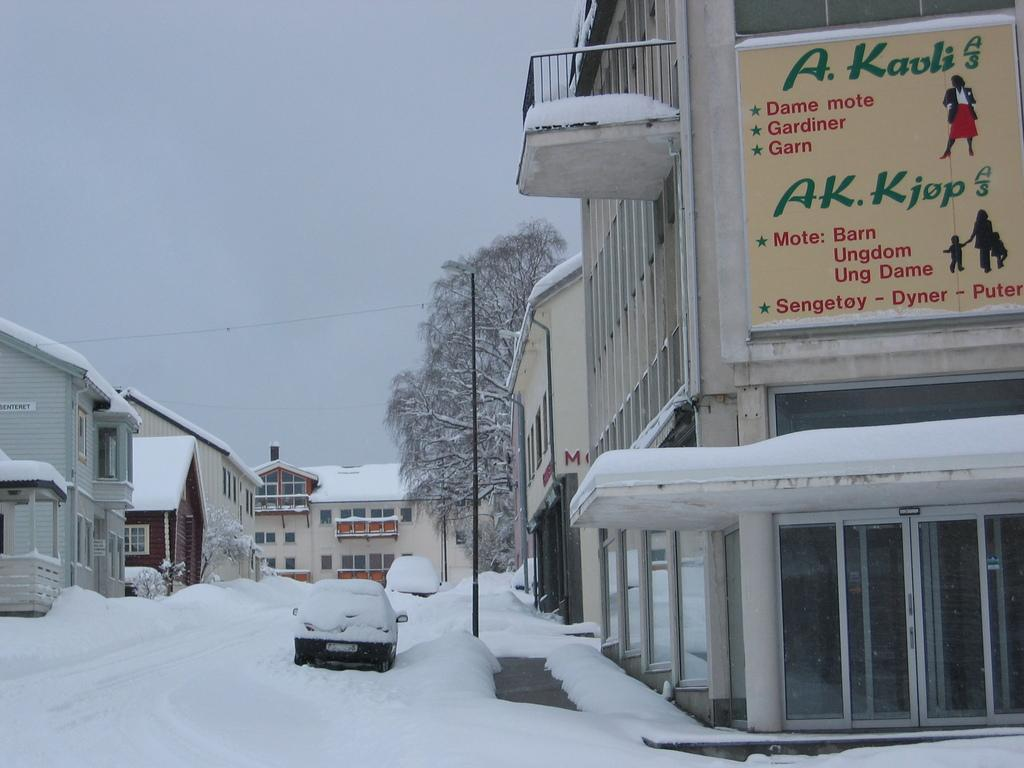What type of structures can be seen in the image? There are buildings in the image. What natural elements are present in the image? There are trees in the image. What are the tall, thin objects in the image? There are poles in the image. What is on the wall in the image? There is a board on a wall in the image. What vehicles can be seen in the image? There are cars on the snow in the image. How are the cars affected by the weather in the image? The cars are covered with snow in the image. What type of coach is present in the image? There is no coach present in the image. What pet can be seen playing with the snow in the image? There are no pets visible in the image; only cars covered with snow are present. 